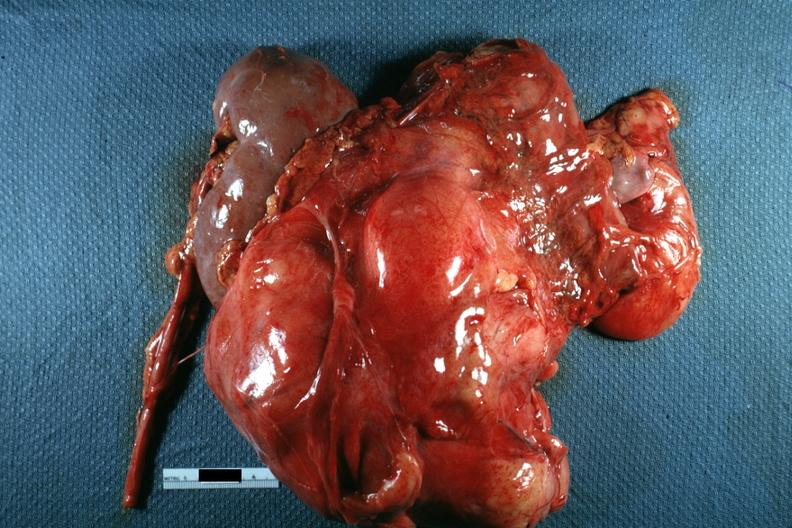how does this image show nodular mass?
Answer the question using a single word or phrase. With kidney seen on one side photo of little use without showing cut surface 